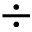Convert formula to latex. <formula><loc_0><loc_0><loc_500><loc_500>\div</formula> 